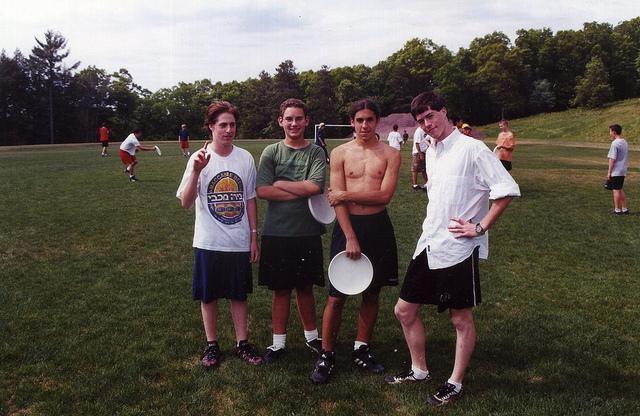How many guys that are shirtless?
Give a very brief answer. 1. How many people are wearing red?
Give a very brief answer. 3. How many people are there?
Give a very brief answer. 4. 